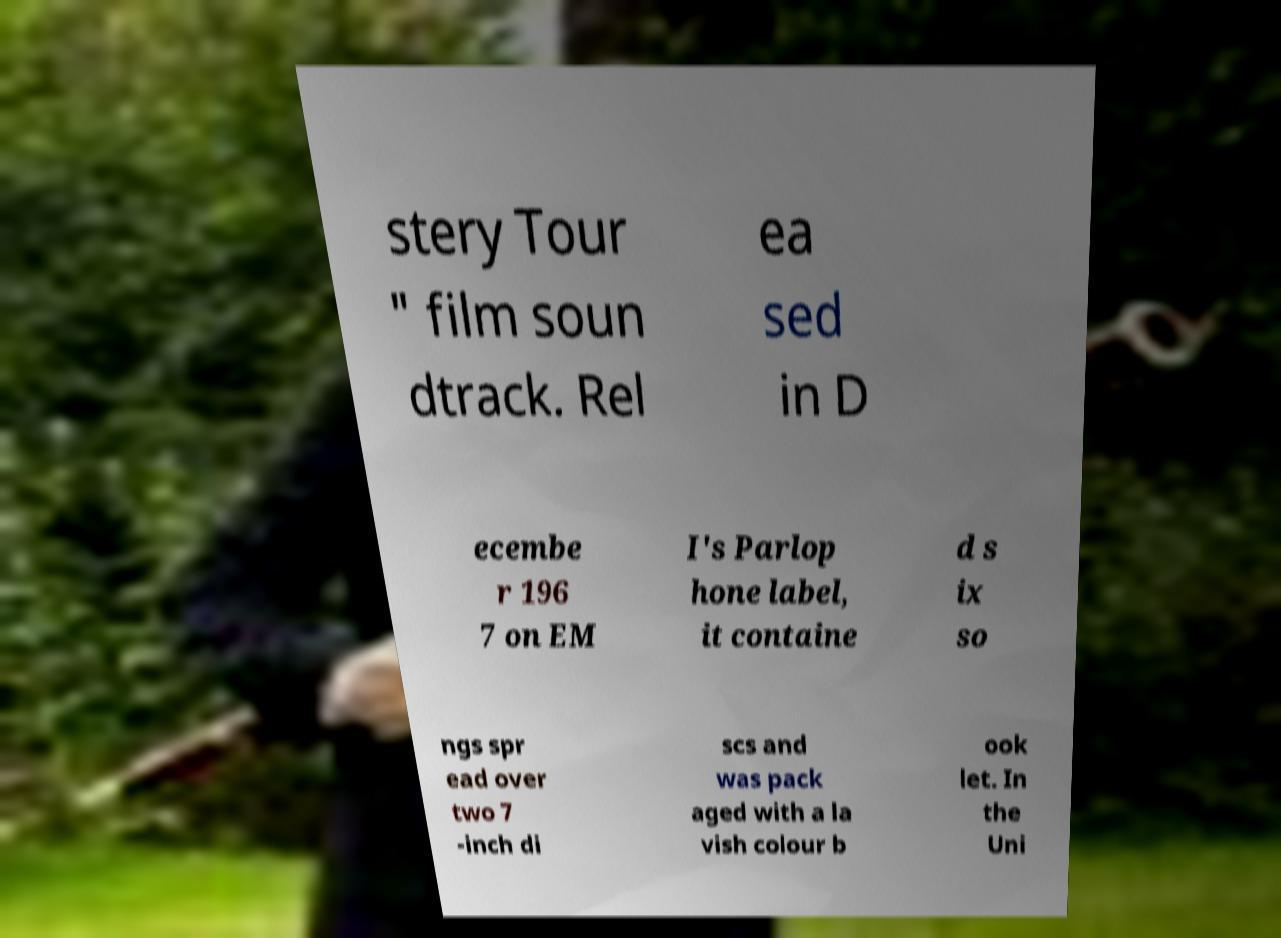There's text embedded in this image that I need extracted. Can you transcribe it verbatim? stery Tour " film soun dtrack. Rel ea sed in D ecembe r 196 7 on EM I's Parlop hone label, it containe d s ix so ngs spr ead over two 7 -inch di scs and was pack aged with a la vish colour b ook let. In the Uni 